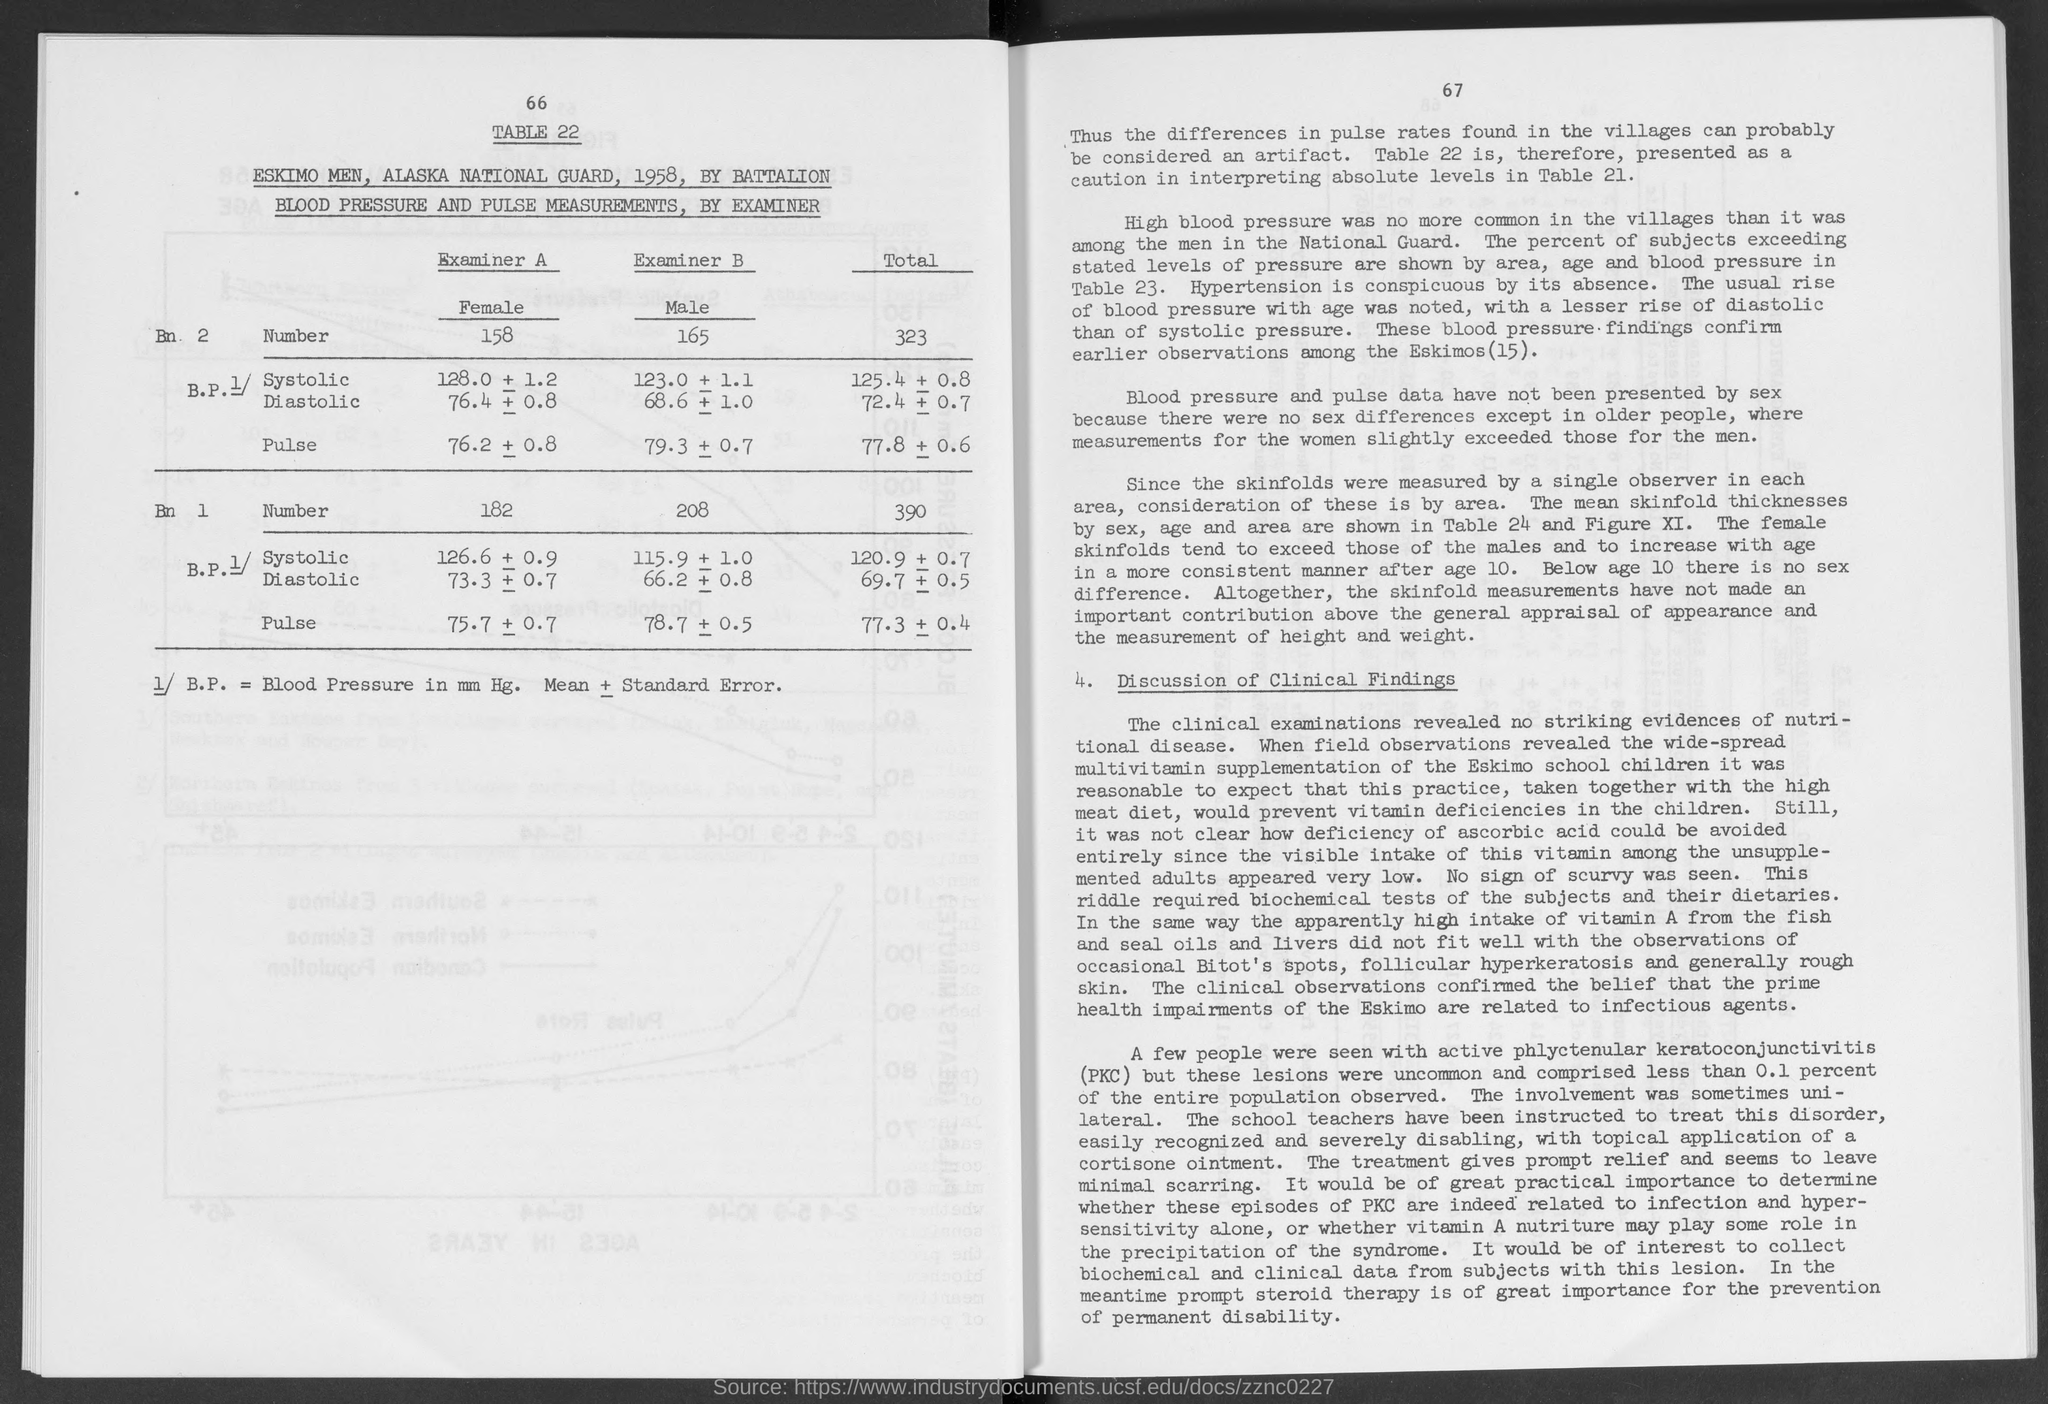What is the table number?
Offer a terse response. 22. What is the number of females in battalion 1?
Keep it short and to the point. 182. What is the number of females in battalion 2?
Your answer should be very brief. 158. What is the number of males in battalion 1?
Make the answer very short. 208. What is the number of males in battalion 2?
Give a very brief answer. 165. What is the total number of members in battalion 2?
Ensure brevity in your answer.  323. What is the total number of members in battalion 1?
Make the answer very short. 390. 